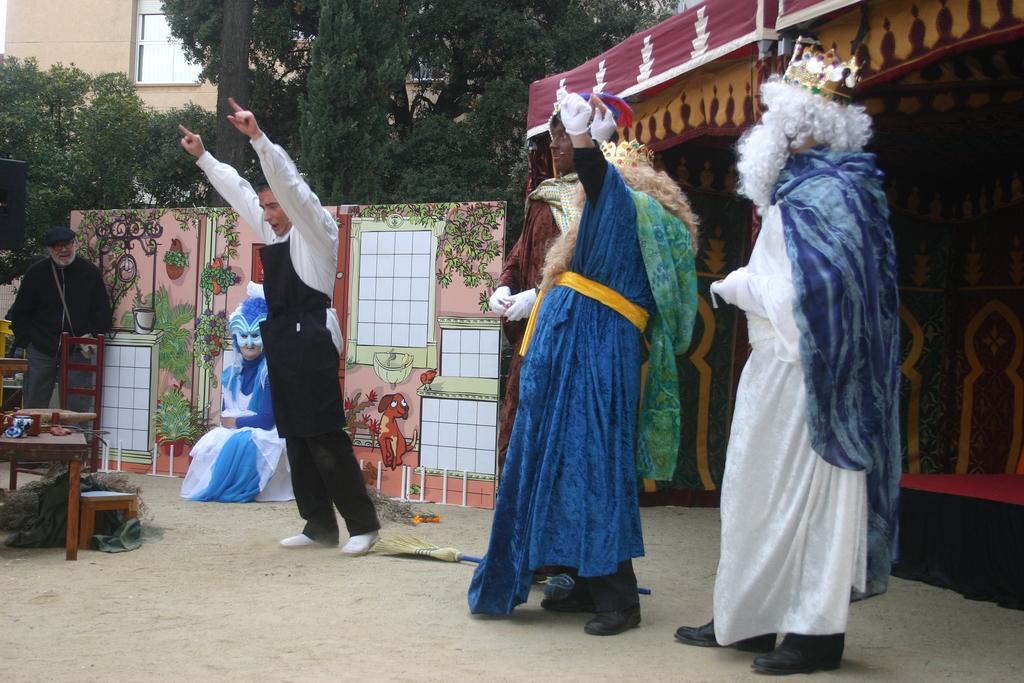Please provide a concise description of this image. In this image there are five persons in the fancy dresses , and there is a tent, animated board, table, chair, trees, building. 